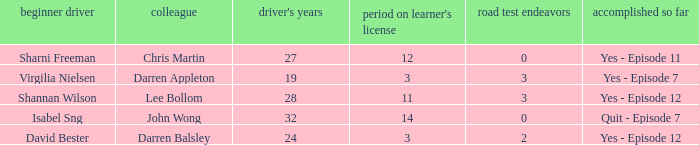Which driver is older than 24 and has more than 0 licence test attempts? Shannan Wilson. 